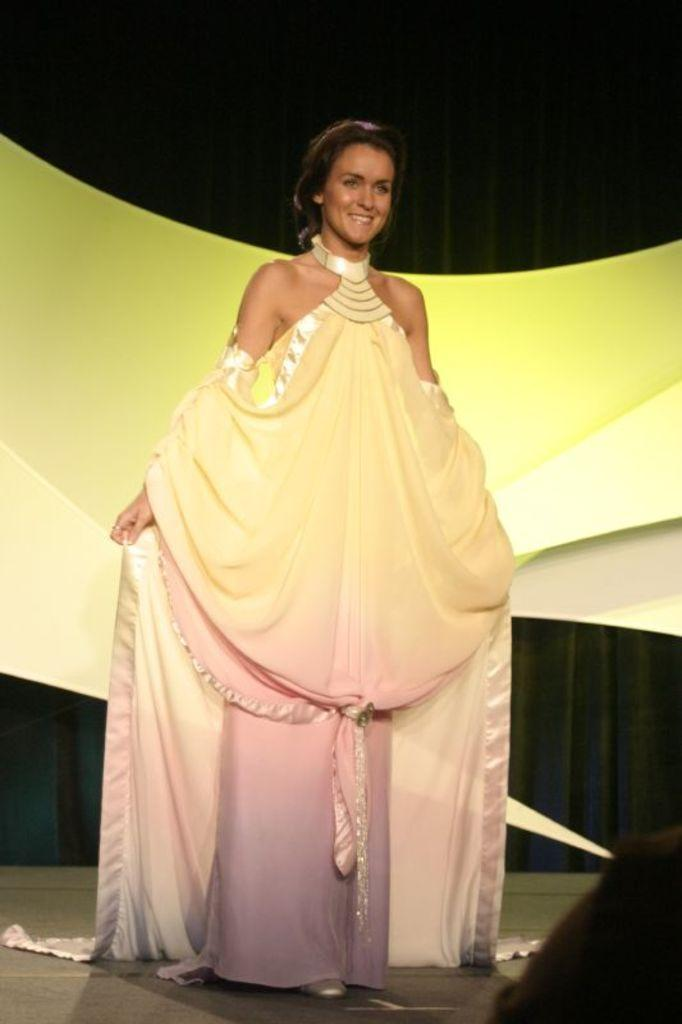Who is the main subject in the image? There is a woman in the image. What is the woman wearing? The woman is wearing a yellow, pink, and purple dress. What is the woman doing in the image? The woman is standing and smiling. What colors are present in the background of the image? The background of the image is yellow and black in color. Can you see any buildings in the background of the image? There are no buildings visible in the image; the background is yellow and black in color. Are there any giants interacting with the woman in the image? There are no giants present in the image; it features a woman standing and smiling. 